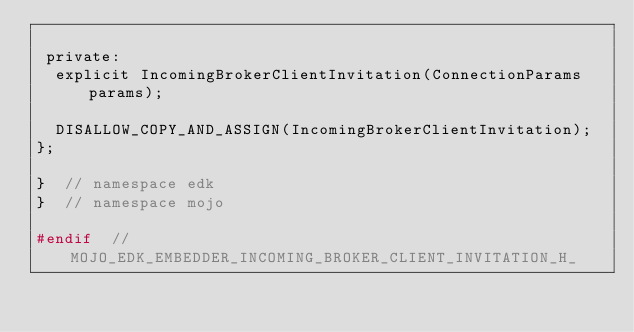Convert code to text. <code><loc_0><loc_0><loc_500><loc_500><_C_>
 private:
  explicit IncomingBrokerClientInvitation(ConnectionParams params);

  DISALLOW_COPY_AND_ASSIGN(IncomingBrokerClientInvitation);
};

}  // namespace edk
}  // namespace mojo

#endif  // MOJO_EDK_EMBEDDER_INCOMING_BROKER_CLIENT_INVITATION_H_
</code> 